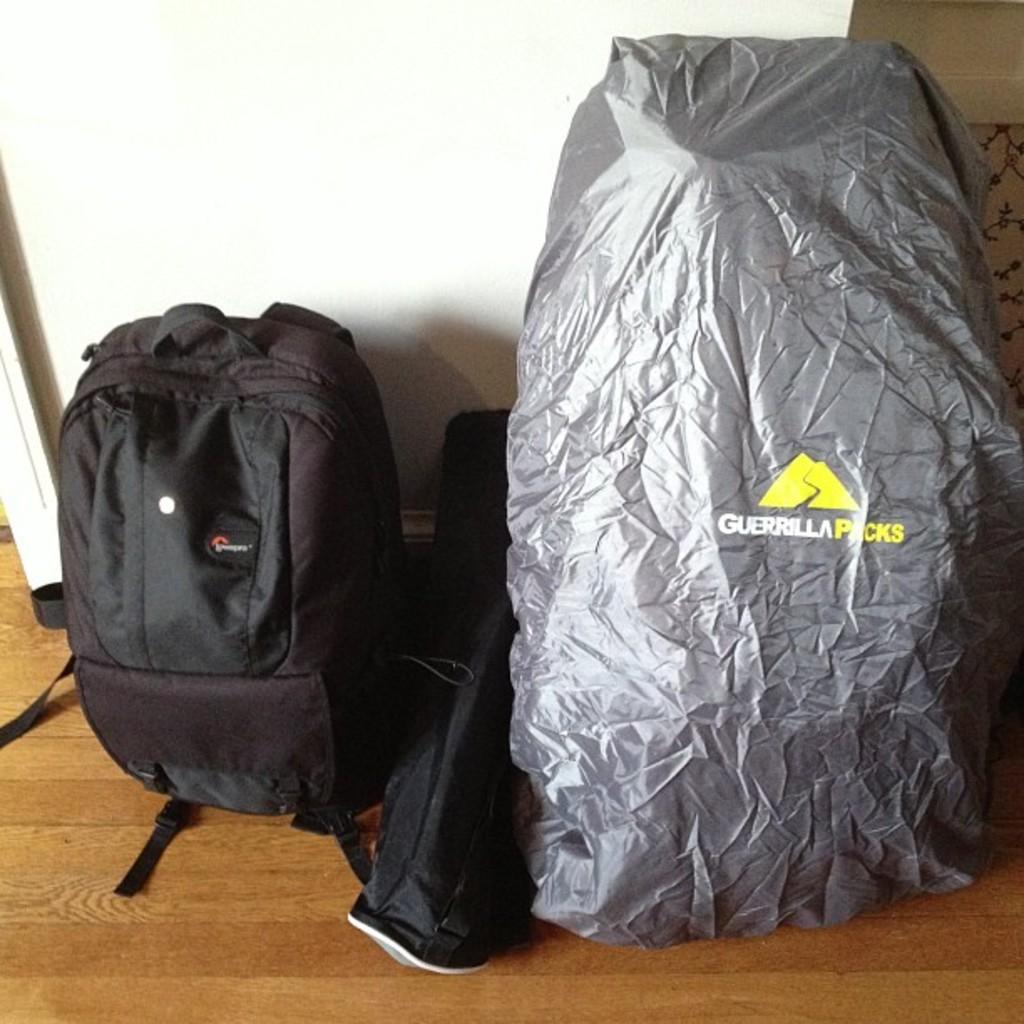What brand is the silver item?
Offer a very short reply. Guerrilla packs. 